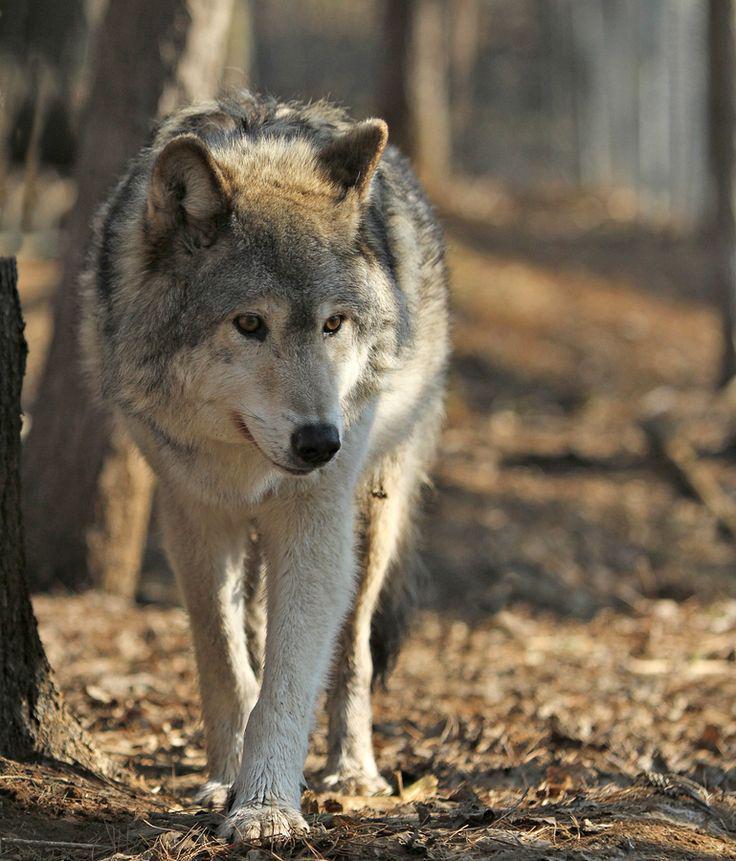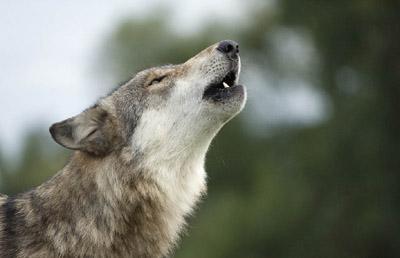The first image is the image on the left, the second image is the image on the right. Assess this claim about the two images: "All images show exactly one wolf.". Correct or not? Answer yes or no. Yes. The first image is the image on the left, the second image is the image on the right. For the images shown, is this caption "There are two wolves" true? Answer yes or no. Yes. 